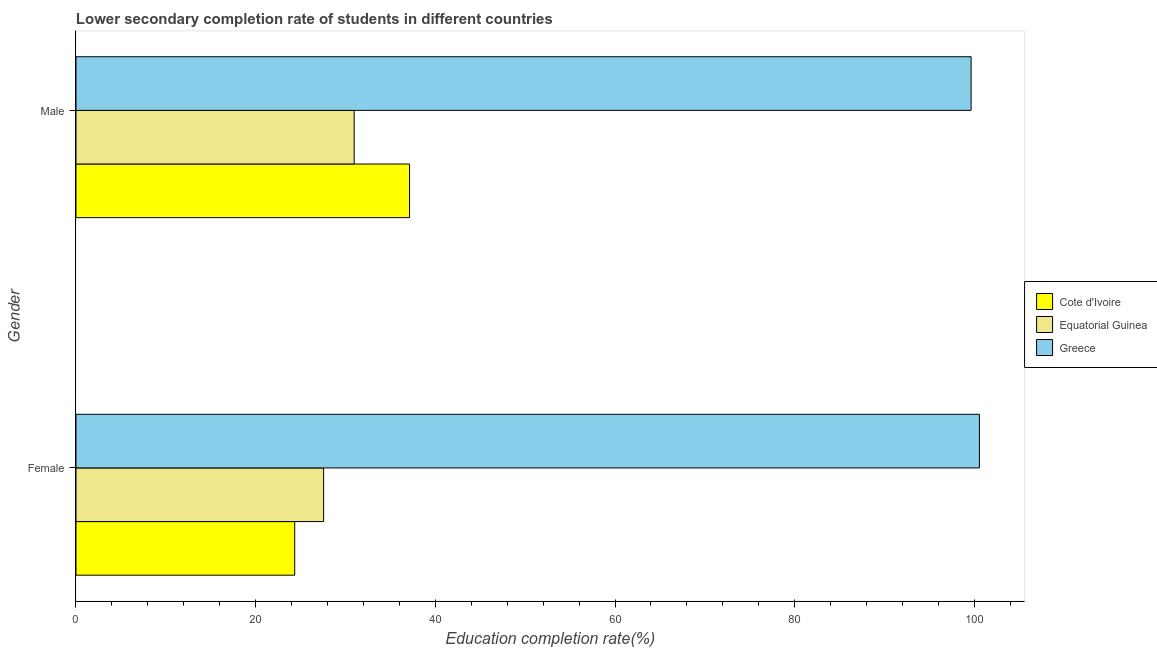Are the number of bars per tick equal to the number of legend labels?
Offer a very short reply. Yes. What is the education completion rate of male students in Equatorial Guinea?
Your answer should be very brief. 30.97. Across all countries, what is the maximum education completion rate of female students?
Your response must be concise. 100.56. Across all countries, what is the minimum education completion rate of female students?
Give a very brief answer. 24.35. In which country was the education completion rate of female students minimum?
Keep it short and to the point. Cote d'Ivoire. What is the total education completion rate of female students in the graph?
Provide a succinct answer. 152.48. What is the difference between the education completion rate of female students in Cote d'Ivoire and that in Greece?
Provide a short and direct response. -76.22. What is the difference between the education completion rate of female students in Greece and the education completion rate of male students in Cote d'Ivoire?
Offer a terse response. 63.43. What is the average education completion rate of male students per country?
Your answer should be compact. 55.91. What is the difference between the education completion rate of male students and education completion rate of female students in Equatorial Guinea?
Ensure brevity in your answer.  3.4. What is the ratio of the education completion rate of female students in Greece to that in Equatorial Guinea?
Offer a terse response. 3.65. What does the 3rd bar from the top in Male represents?
Offer a terse response. Cote d'Ivoire. What does the 2nd bar from the bottom in Female represents?
Your answer should be very brief. Equatorial Guinea. How many bars are there?
Keep it short and to the point. 6. Are all the bars in the graph horizontal?
Your response must be concise. Yes. What is the difference between two consecutive major ticks on the X-axis?
Give a very brief answer. 20. Are the values on the major ticks of X-axis written in scientific E-notation?
Your answer should be compact. No. Does the graph contain any zero values?
Offer a very short reply. No. Where does the legend appear in the graph?
Offer a very short reply. Center right. How many legend labels are there?
Give a very brief answer. 3. How are the legend labels stacked?
Ensure brevity in your answer.  Vertical. What is the title of the graph?
Offer a very short reply. Lower secondary completion rate of students in different countries. What is the label or title of the X-axis?
Your response must be concise. Education completion rate(%). What is the label or title of the Y-axis?
Your answer should be very brief. Gender. What is the Education completion rate(%) in Cote d'Ivoire in Female?
Provide a succinct answer. 24.35. What is the Education completion rate(%) of Equatorial Guinea in Female?
Give a very brief answer. 27.57. What is the Education completion rate(%) of Greece in Female?
Give a very brief answer. 100.56. What is the Education completion rate(%) of Cote d'Ivoire in Male?
Your answer should be compact. 37.13. What is the Education completion rate(%) in Equatorial Guinea in Male?
Give a very brief answer. 30.97. What is the Education completion rate(%) of Greece in Male?
Provide a short and direct response. 99.64. Across all Gender, what is the maximum Education completion rate(%) in Cote d'Ivoire?
Ensure brevity in your answer.  37.13. Across all Gender, what is the maximum Education completion rate(%) in Equatorial Guinea?
Give a very brief answer. 30.97. Across all Gender, what is the maximum Education completion rate(%) in Greece?
Offer a terse response. 100.56. Across all Gender, what is the minimum Education completion rate(%) in Cote d'Ivoire?
Make the answer very short. 24.35. Across all Gender, what is the minimum Education completion rate(%) in Equatorial Guinea?
Your answer should be very brief. 27.57. Across all Gender, what is the minimum Education completion rate(%) in Greece?
Keep it short and to the point. 99.64. What is the total Education completion rate(%) of Cote d'Ivoire in the graph?
Your response must be concise. 61.48. What is the total Education completion rate(%) in Equatorial Guinea in the graph?
Provide a short and direct response. 58.53. What is the total Education completion rate(%) in Greece in the graph?
Offer a terse response. 200.21. What is the difference between the Education completion rate(%) in Cote d'Ivoire in Female and that in Male?
Make the answer very short. -12.79. What is the difference between the Education completion rate(%) of Equatorial Guinea in Female and that in Male?
Offer a terse response. -3.4. What is the difference between the Education completion rate(%) of Greece in Female and that in Male?
Give a very brief answer. 0.92. What is the difference between the Education completion rate(%) in Cote d'Ivoire in Female and the Education completion rate(%) in Equatorial Guinea in Male?
Provide a short and direct response. -6.62. What is the difference between the Education completion rate(%) in Cote d'Ivoire in Female and the Education completion rate(%) in Greece in Male?
Ensure brevity in your answer.  -75.29. What is the difference between the Education completion rate(%) of Equatorial Guinea in Female and the Education completion rate(%) of Greece in Male?
Give a very brief answer. -72.07. What is the average Education completion rate(%) in Cote d'Ivoire per Gender?
Ensure brevity in your answer.  30.74. What is the average Education completion rate(%) of Equatorial Guinea per Gender?
Make the answer very short. 29.27. What is the average Education completion rate(%) in Greece per Gender?
Provide a succinct answer. 100.1. What is the difference between the Education completion rate(%) of Cote d'Ivoire and Education completion rate(%) of Equatorial Guinea in Female?
Your answer should be very brief. -3.22. What is the difference between the Education completion rate(%) in Cote d'Ivoire and Education completion rate(%) in Greece in Female?
Make the answer very short. -76.22. What is the difference between the Education completion rate(%) of Equatorial Guinea and Education completion rate(%) of Greece in Female?
Keep it short and to the point. -73. What is the difference between the Education completion rate(%) of Cote d'Ivoire and Education completion rate(%) of Equatorial Guinea in Male?
Keep it short and to the point. 6.17. What is the difference between the Education completion rate(%) in Cote d'Ivoire and Education completion rate(%) in Greece in Male?
Offer a very short reply. -62.51. What is the difference between the Education completion rate(%) in Equatorial Guinea and Education completion rate(%) in Greece in Male?
Ensure brevity in your answer.  -68.67. What is the ratio of the Education completion rate(%) in Cote d'Ivoire in Female to that in Male?
Make the answer very short. 0.66. What is the ratio of the Education completion rate(%) in Equatorial Guinea in Female to that in Male?
Provide a succinct answer. 0.89. What is the ratio of the Education completion rate(%) in Greece in Female to that in Male?
Offer a terse response. 1.01. What is the difference between the highest and the second highest Education completion rate(%) in Cote d'Ivoire?
Provide a short and direct response. 12.79. What is the difference between the highest and the second highest Education completion rate(%) of Equatorial Guinea?
Keep it short and to the point. 3.4. What is the difference between the highest and the second highest Education completion rate(%) in Greece?
Make the answer very short. 0.92. What is the difference between the highest and the lowest Education completion rate(%) of Cote d'Ivoire?
Your response must be concise. 12.79. What is the difference between the highest and the lowest Education completion rate(%) of Equatorial Guinea?
Your answer should be compact. 3.4. What is the difference between the highest and the lowest Education completion rate(%) in Greece?
Offer a terse response. 0.92. 